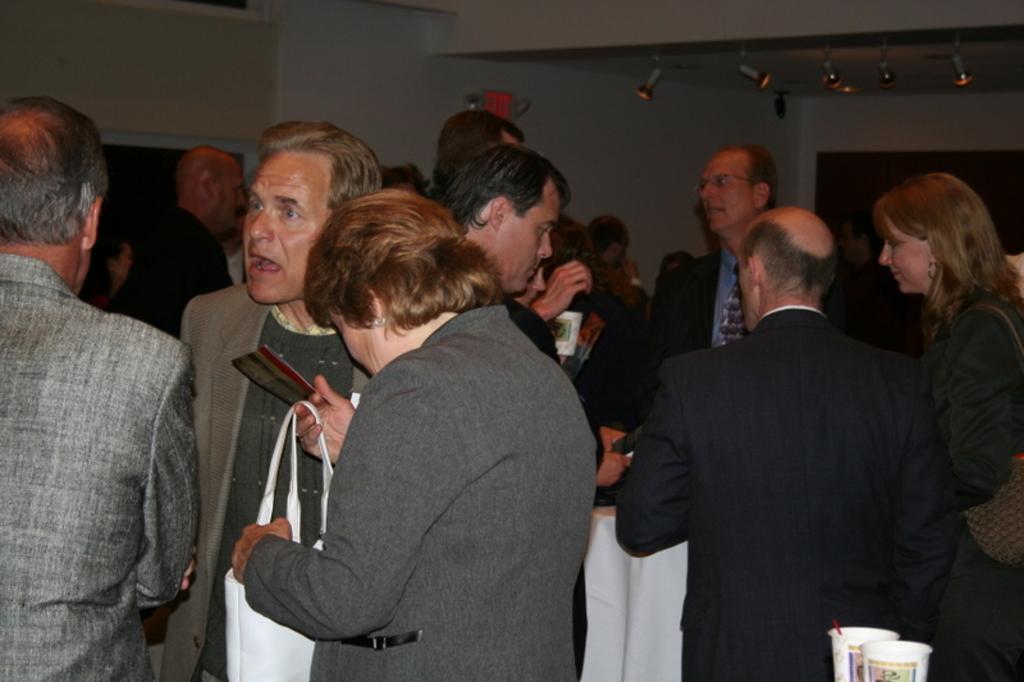In one or two sentences, can you explain what this image depicts? There are people and this person holding a bag. In the background we can see wall and lights. In the bottom right side of the image we can see glasses. 